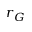<formula> <loc_0><loc_0><loc_500><loc_500>r _ { G }</formula> 